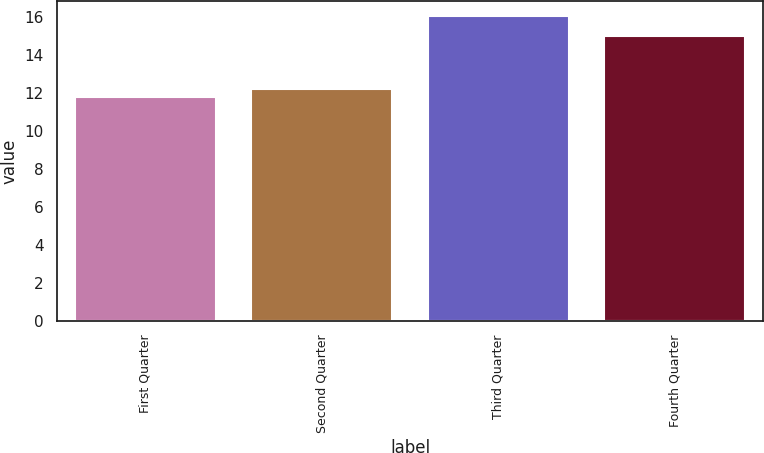Convert chart to OTSL. <chart><loc_0><loc_0><loc_500><loc_500><bar_chart><fcel>First Quarter<fcel>Second Quarter<fcel>Third Quarter<fcel>Fourth Quarter<nl><fcel>11.81<fcel>12.23<fcel>16.05<fcel>15.02<nl></chart> 